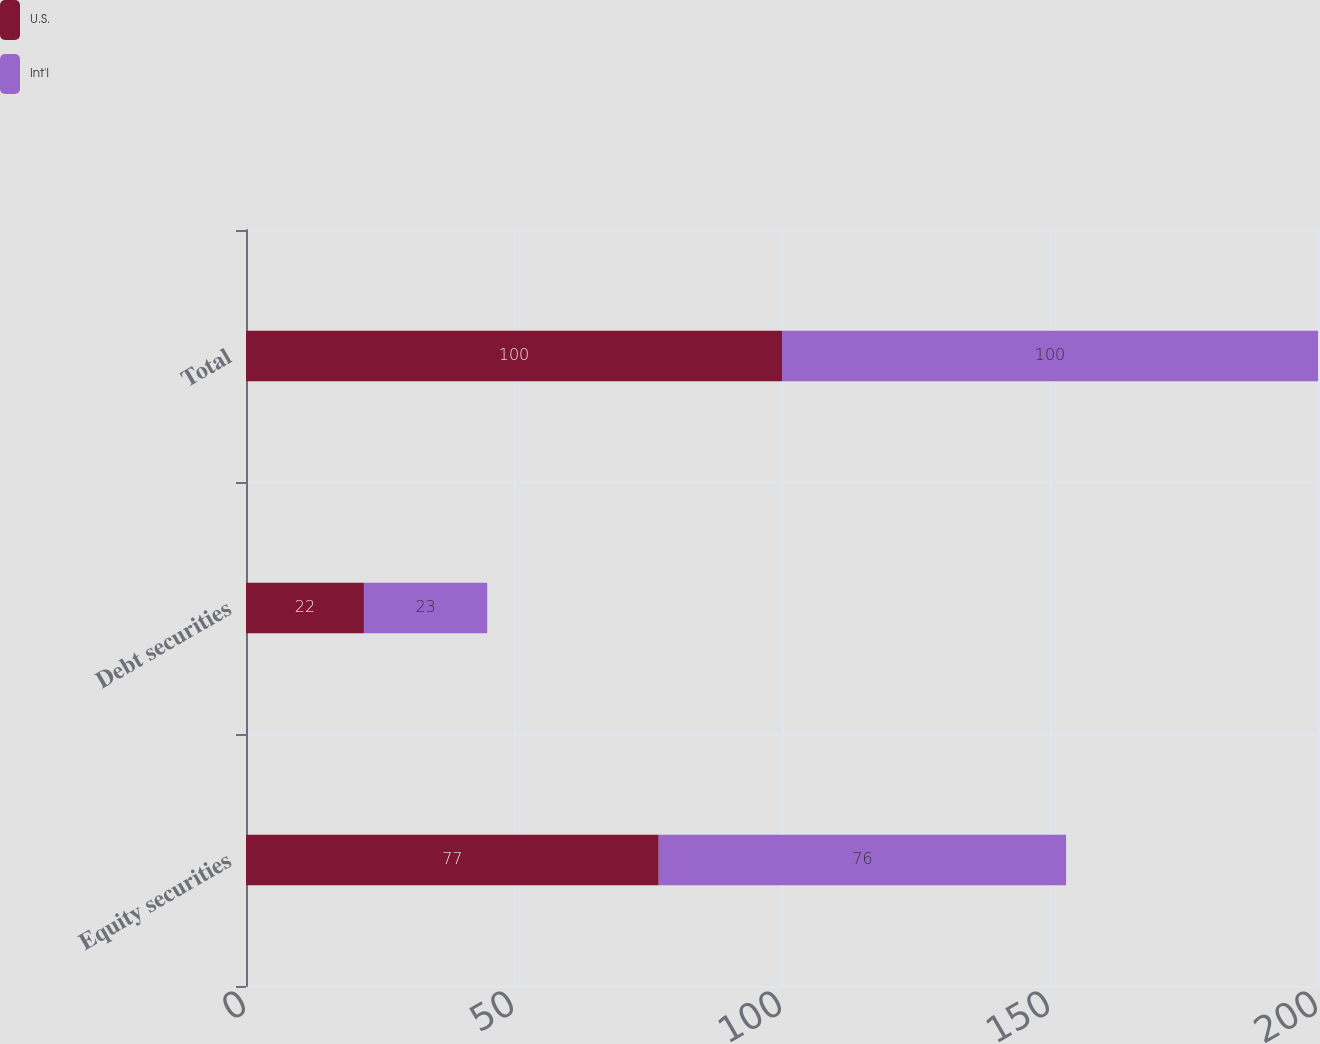<chart> <loc_0><loc_0><loc_500><loc_500><stacked_bar_chart><ecel><fcel>Equity securities<fcel>Debt securities<fcel>Total<nl><fcel>U.S.<fcel>77<fcel>22<fcel>100<nl><fcel>Int'l<fcel>76<fcel>23<fcel>100<nl></chart> 